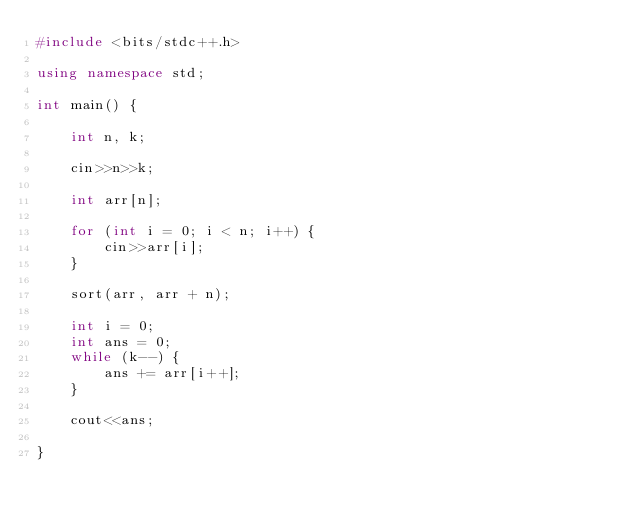<code> <loc_0><loc_0><loc_500><loc_500><_C++_>#include <bits/stdc++.h>

using namespace std;

int main() {
	
	int n, k;
	
	cin>>n>>k;
	
	int arr[n];
	
	for (int i = 0; i < n; i++) {
		cin>>arr[i];
	}
	
	sort(arr, arr + n);
	
	int i = 0;
	int ans = 0;
	while (k--) {
		ans += arr[i++];
	}
	
	cout<<ans;
	
}</code> 